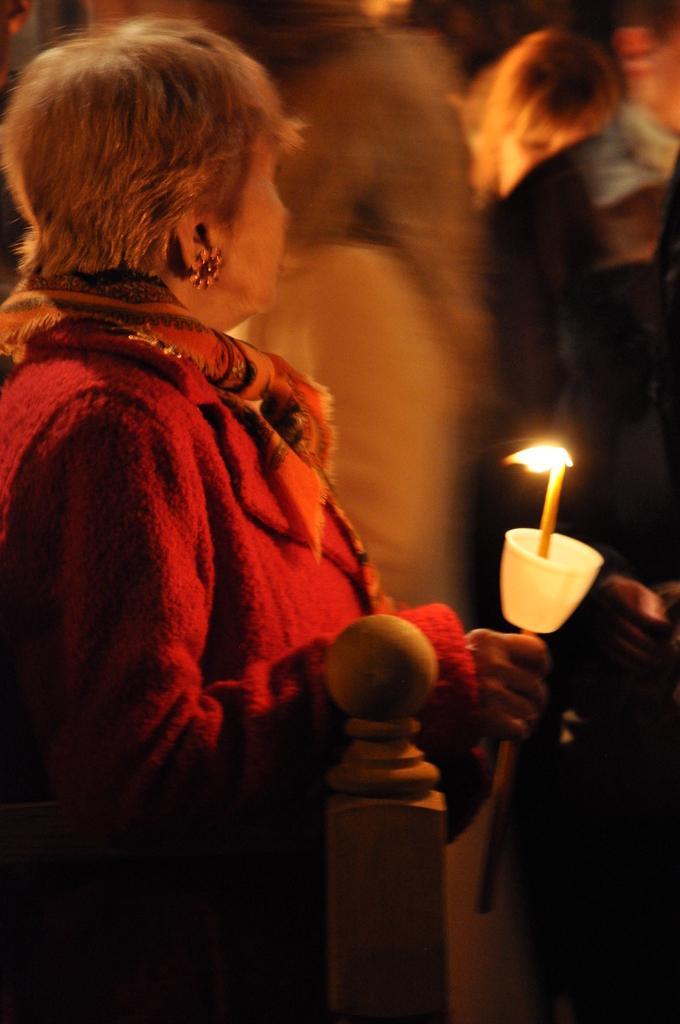Please provide a concise description of this image. In this picture we can see a woman is standing and holding a candle in the front, in the background there are some people. 